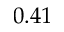Convert formula to latex. <formula><loc_0><loc_0><loc_500><loc_500>0 . 4 1</formula> 